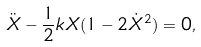Convert formula to latex. <formula><loc_0><loc_0><loc_500><loc_500>\ddot { X } - \frac { 1 } { 2 } k X ( 1 - 2 \dot { X } ^ { 2 } ) = 0 ,</formula> 